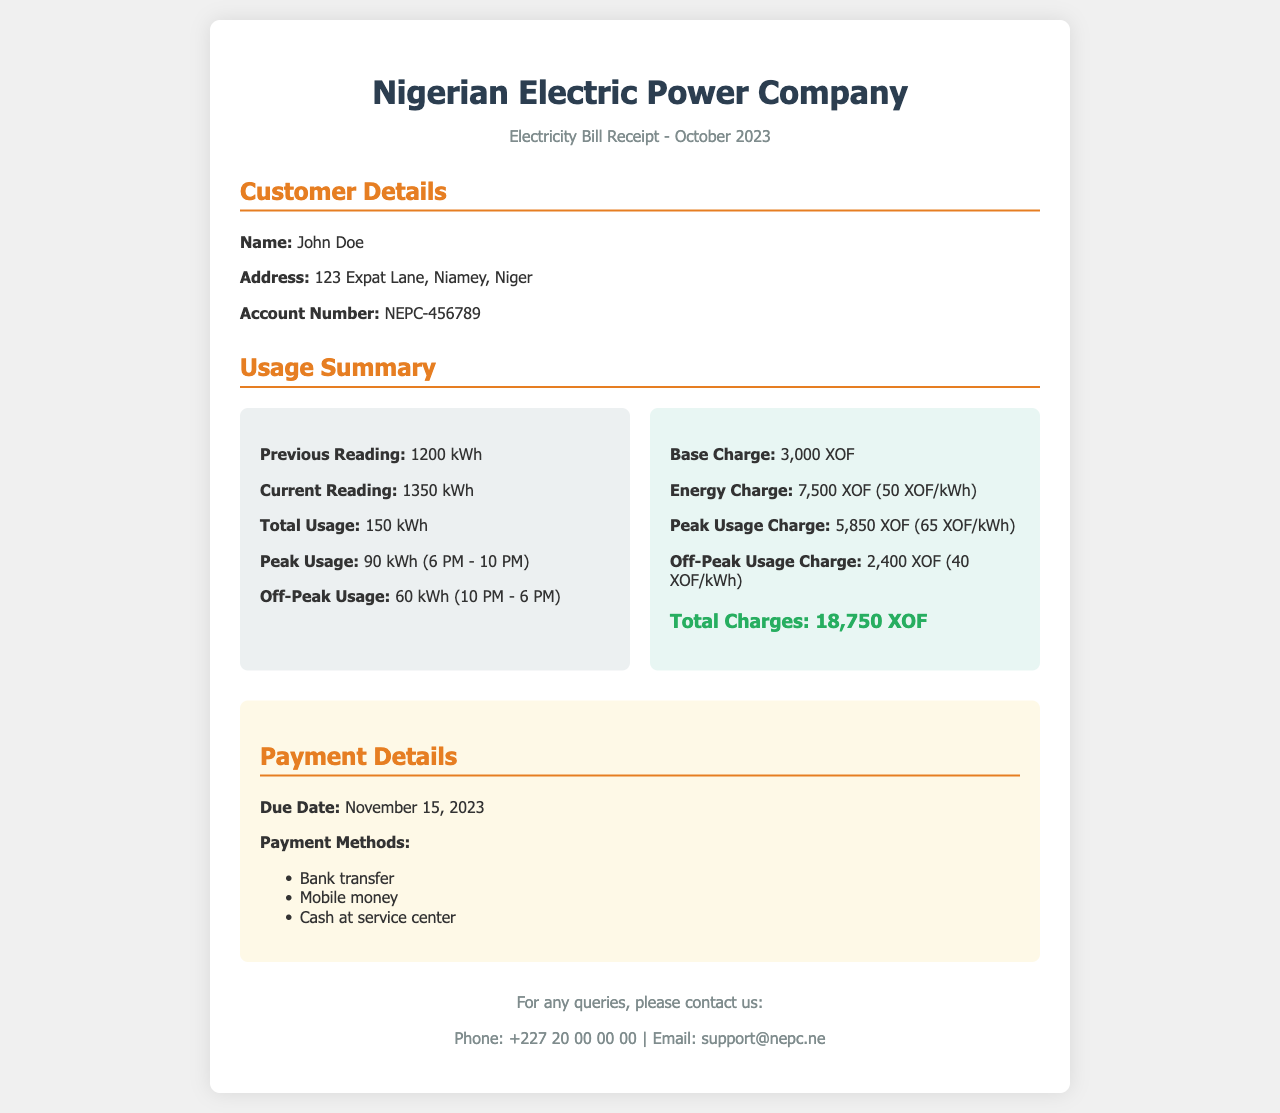What is the customer's name? The customer's name is explicitly stated in the document under Customer Details.
Answer: John Doe What is the total usage in kilowatt-hours? The total usage is listed in the Usage Summary section as the difference between the previous and current readings.
Answer: 150 kWh What is the due date for the payment? The due date is provided in the Payment Details section of the receipt.
Answer: November 15, 2023 How much is the Peak Usage Charge? The Peak Usage Charge is specifically mentioned in the Charges section of the document.
Answer: 5,850 XOF What is the account number? The account number is included in the Customer Details section of the receipt.
Answer: NEPC-456789 What is the total amount of charges? The total charges are clearly outlined in the Charges section at the end of the summary.
Answer: 18,750 XOF What method of payment is NOT mentioned? The document outlines specific payment methods, and this question asks to identify one that is not listed.
Answer: Cheque How many kilowatt-hours were used during peak usage? The peak usage is specified in the Usage Summary section as the quantity during peak hours.
Answer: 90 kWh What is the base charge amount? The base charge amount is listed explicitly in the Charges section.
Answer: 3,000 XOF 